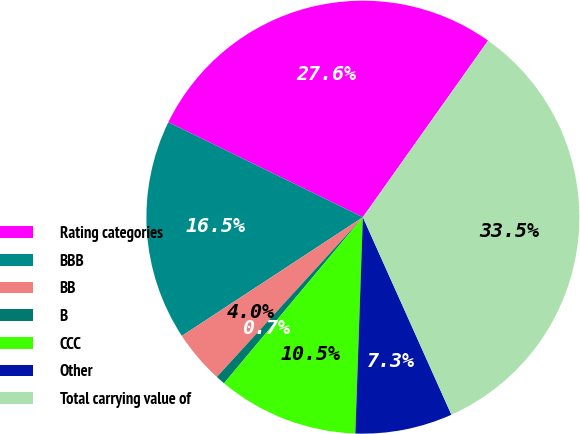Convert chart to OTSL. <chart><loc_0><loc_0><loc_500><loc_500><pie_chart><fcel>Rating categories<fcel>BBB<fcel>BB<fcel>B<fcel>CCC<fcel>Other<fcel>Total carrying value of<nl><fcel>27.59%<fcel>16.47%<fcel>3.98%<fcel>0.7%<fcel>10.53%<fcel>7.26%<fcel>33.48%<nl></chart> 